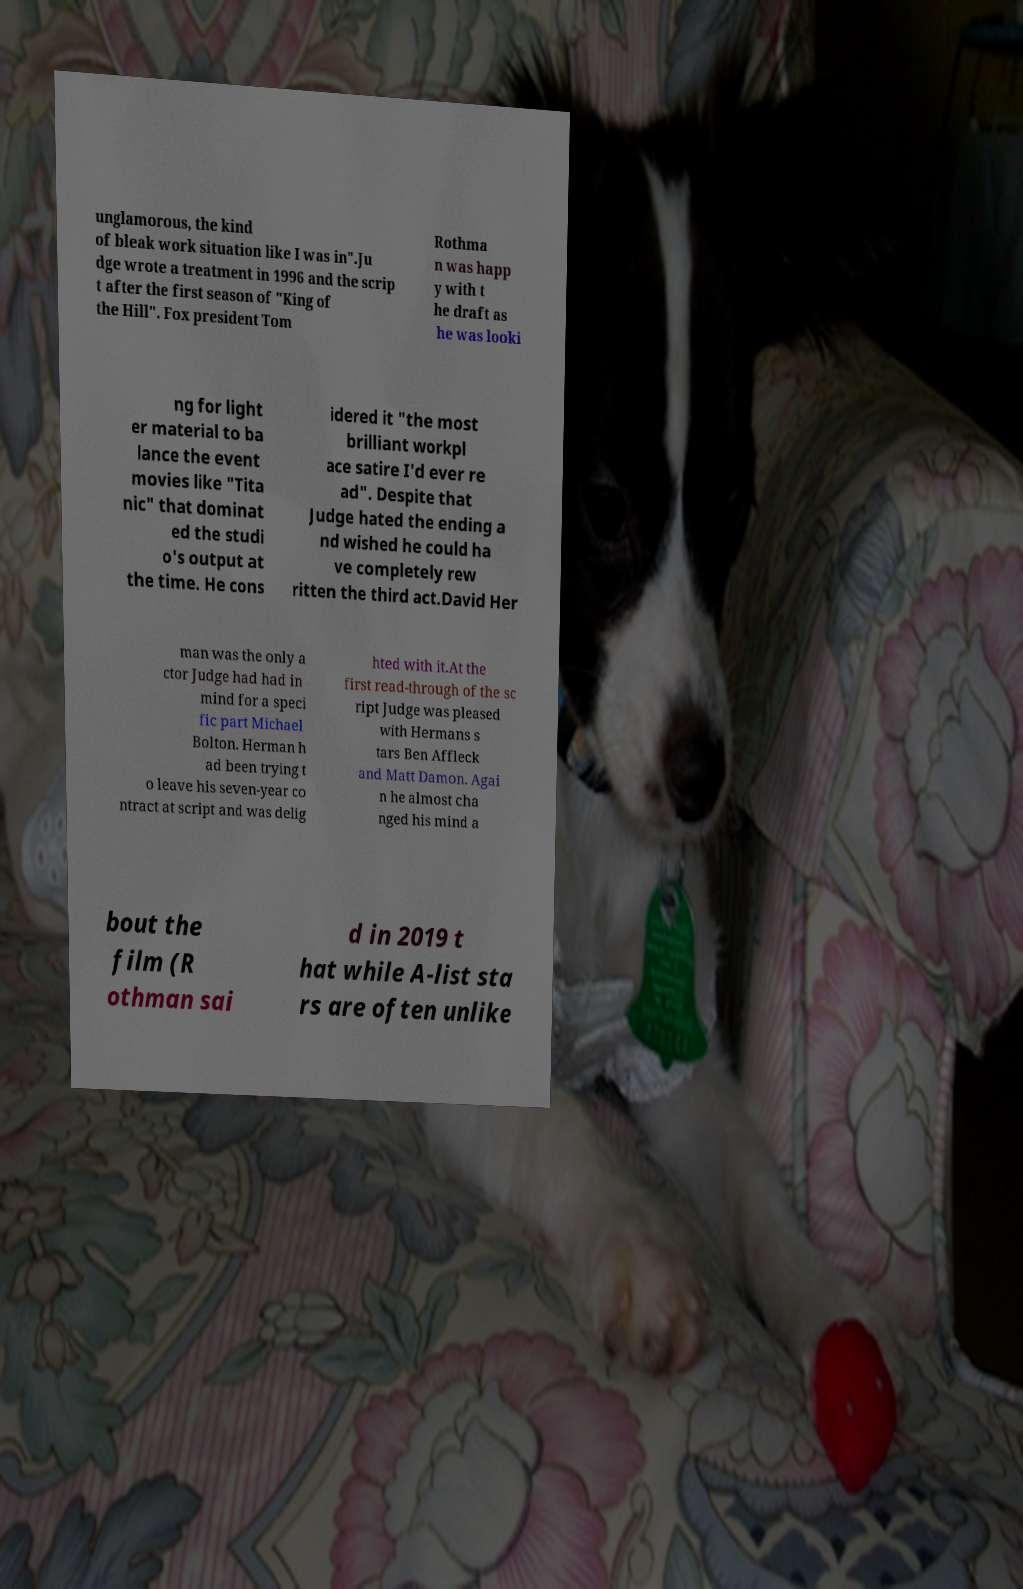Please read and relay the text visible in this image. What does it say? unglamorous, the kind of bleak work situation like I was in".Ju dge wrote a treatment in 1996 and the scrip t after the first season of "King of the Hill". Fox president Tom Rothma n was happ y with t he draft as he was looki ng for light er material to ba lance the event movies like "Tita nic" that dominat ed the studi o's output at the time. He cons idered it "the most brilliant workpl ace satire I'd ever re ad". Despite that Judge hated the ending a nd wished he could ha ve completely rew ritten the third act.David Her man was the only a ctor Judge had had in mind for a speci fic part Michael Bolton. Herman h ad been trying t o leave his seven-year co ntract at script and was delig hted with it.At the first read-through of the sc ript Judge was pleased with Hermans s tars Ben Affleck and Matt Damon. Agai n he almost cha nged his mind a bout the film (R othman sai d in 2019 t hat while A-list sta rs are often unlike 